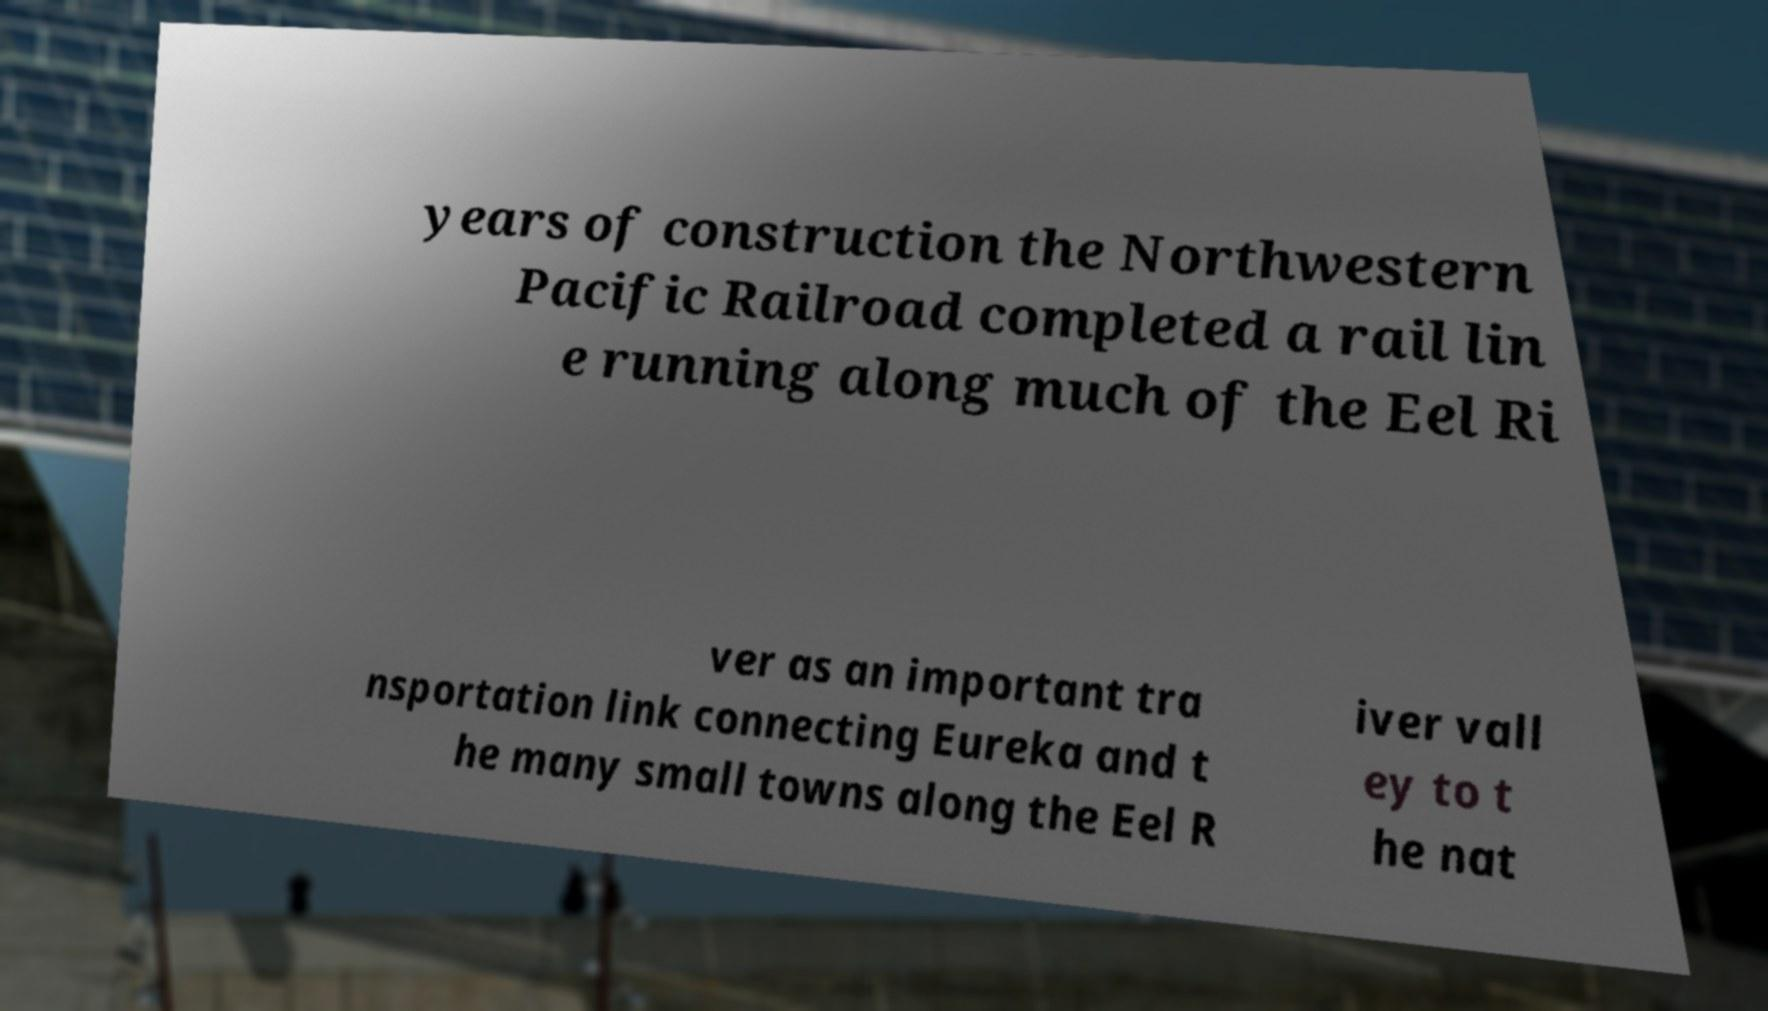Could you extract and type out the text from this image? years of construction the Northwestern Pacific Railroad completed a rail lin e running along much of the Eel Ri ver as an important tra nsportation link connecting Eureka and t he many small towns along the Eel R iver vall ey to t he nat 